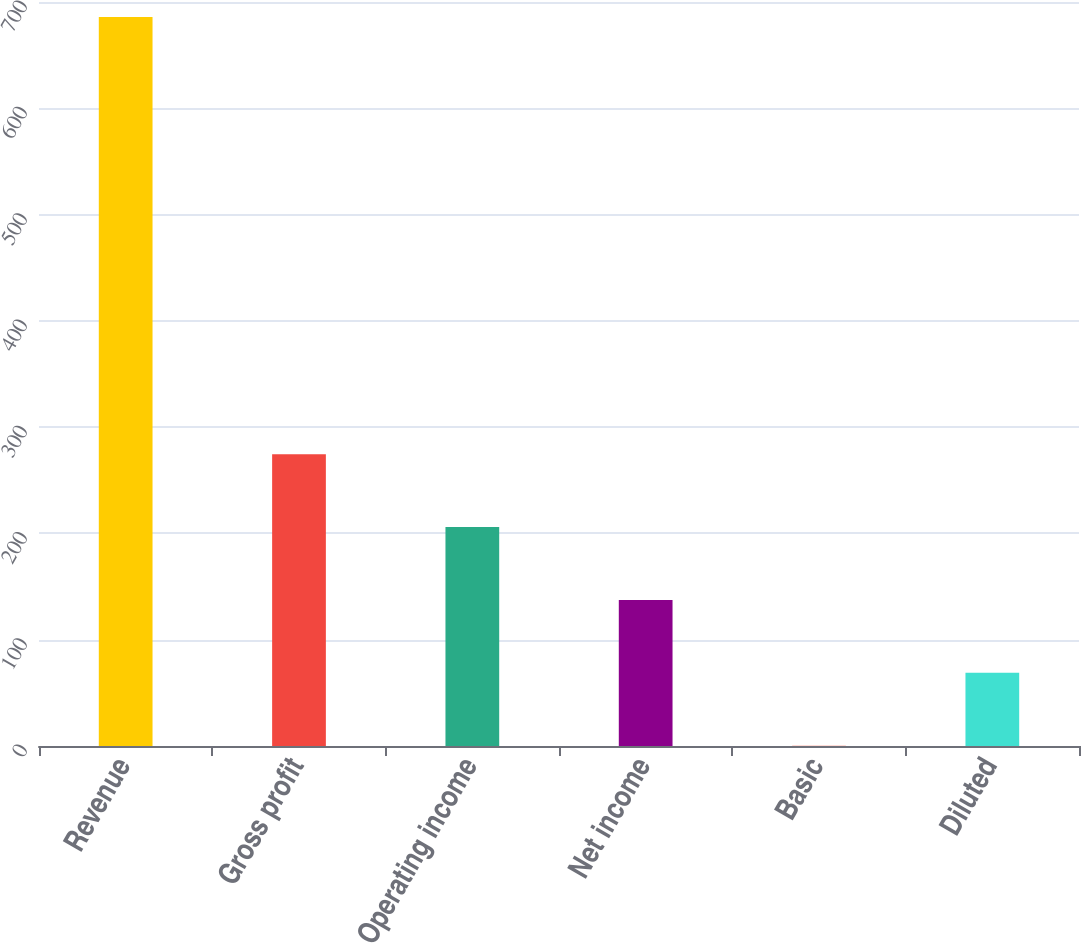Convert chart to OTSL. <chart><loc_0><loc_0><loc_500><loc_500><bar_chart><fcel>Revenue<fcel>Gross profit<fcel>Operating income<fcel>Net income<fcel>Basic<fcel>Diluted<nl><fcel>686<fcel>274.58<fcel>206.01<fcel>137.44<fcel>0.3<fcel>68.87<nl></chart> 